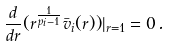<formula> <loc_0><loc_0><loc_500><loc_500>\frac { d } { d r } ( r ^ { \frac { 1 } { p _ { i } - 1 } } \bar { v } _ { i } ( r ) ) | _ { r = 1 } = 0 \, .</formula> 